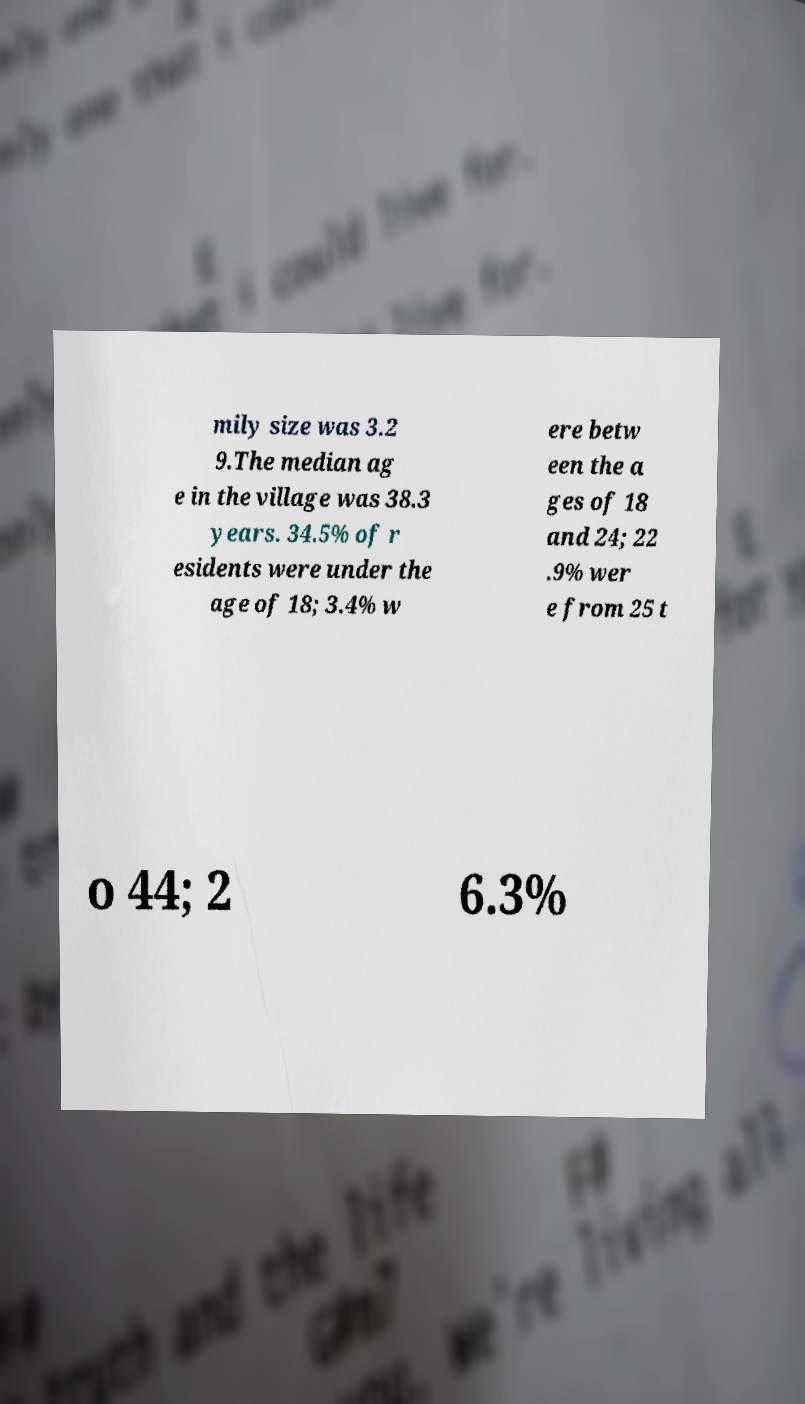Please identify and transcribe the text found in this image. mily size was 3.2 9.The median ag e in the village was 38.3 years. 34.5% of r esidents were under the age of 18; 3.4% w ere betw een the a ges of 18 and 24; 22 .9% wer e from 25 t o 44; 2 6.3% 